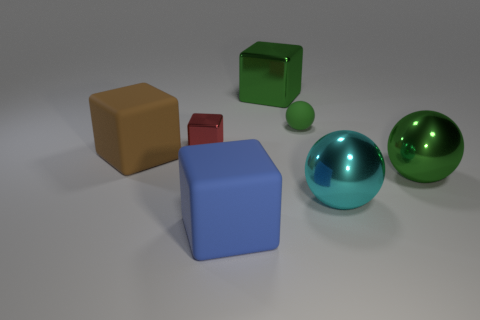Subtract all large green balls. How many balls are left? 2 Subtract all gray cylinders. How many green balls are left? 2 Add 2 brown blocks. How many objects exist? 9 Subtract all green balls. How many balls are left? 1 Add 2 big blue rubber cylinders. How many big blue rubber cylinders exist? 2 Subtract 0 gray blocks. How many objects are left? 7 Subtract all spheres. How many objects are left? 4 Subtract all brown spheres. Subtract all cyan blocks. How many spheres are left? 3 Subtract all brown matte objects. Subtract all big green metal blocks. How many objects are left? 5 Add 3 tiny red blocks. How many tiny red blocks are left? 4 